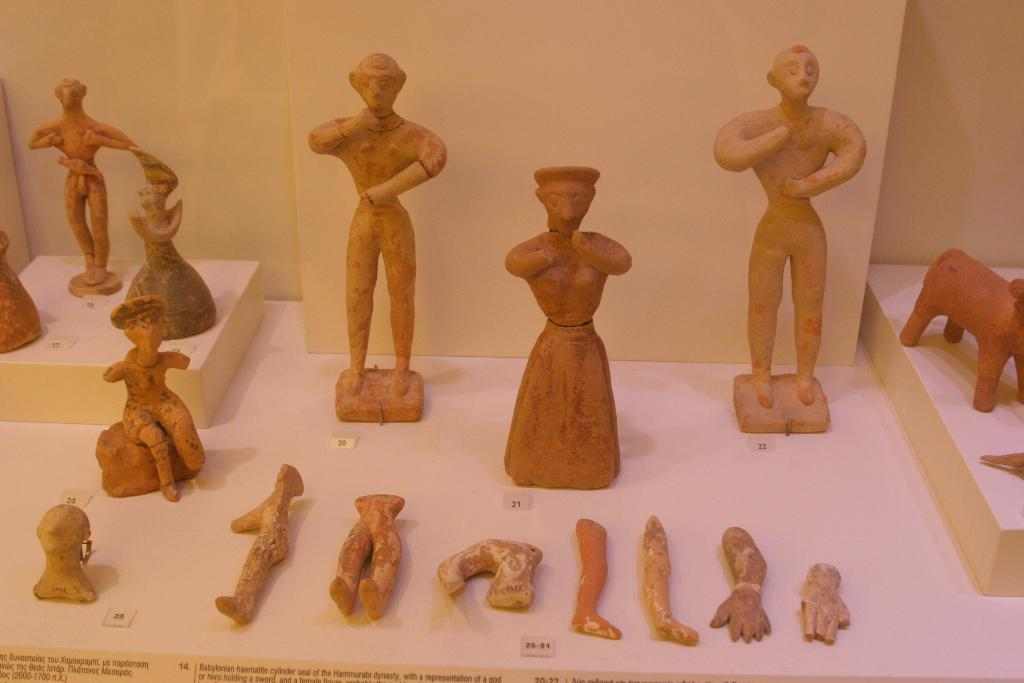What type of objects can be seen in the image? There are statues and antique pieces in the image. How are the statues and antique pieces arranged in the image? The statues and antique pieces are kept on the ground. What type of committee is responsible for the maintenance of the property in the image? There is no mention of a committee or property in the image; it only features statues and antique pieces. 